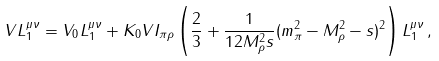Convert formula to latex. <formula><loc_0><loc_0><loc_500><loc_500>V L _ { 1 } ^ { \mu \nu } = V _ { 0 } L _ { 1 } ^ { \mu \nu } + K _ { 0 } V I _ { \pi \rho } \left ( \frac { 2 } { 3 } + \frac { 1 } { 1 2 M _ { \rho } ^ { 2 } s } ( m _ { \pi } ^ { 2 } - M _ { \rho } ^ { 2 } - s ) ^ { 2 } \right ) L _ { 1 } ^ { \mu \nu } \, ,</formula> 